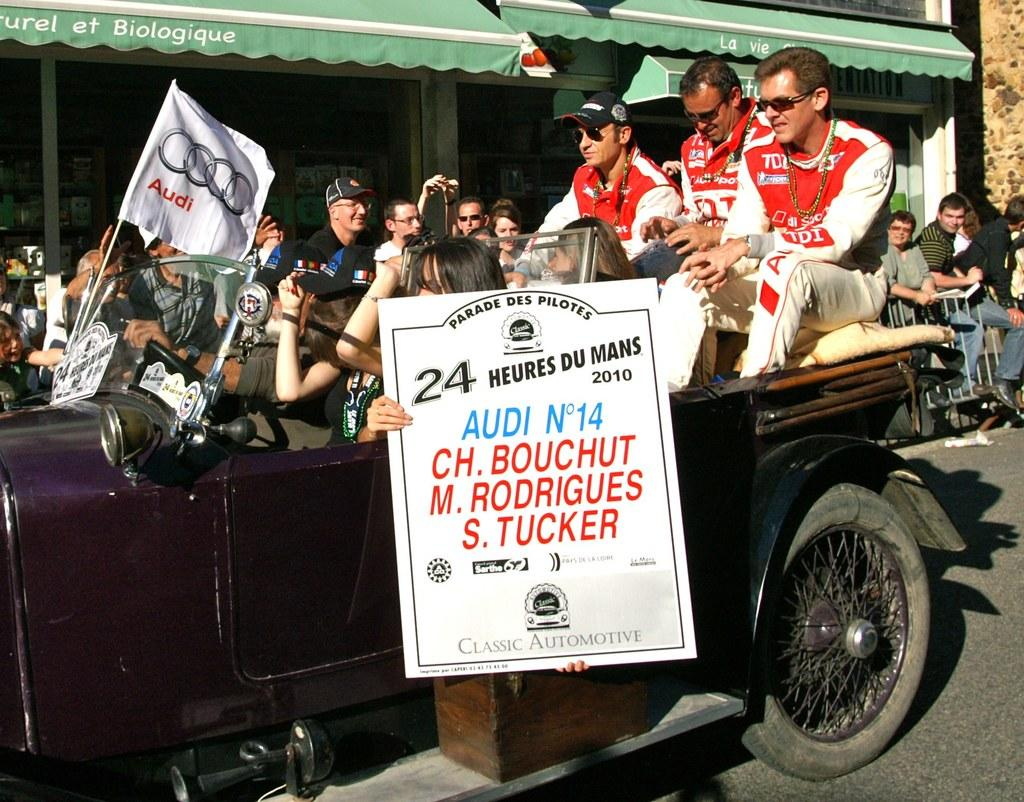How many people are in the image? There are people in the image, but the exact number is not specified. What are some people doing in the image? Some people are sitting in a vehicle, and there is a person holding a board. What can be seen on the road in the image? There is a banner with a stick in the image. What is visible in the background of the image? There are stories and a wall in the background. What flavor of apple is being discussed in the image? There is no mention of apples or any flavors in the image. 